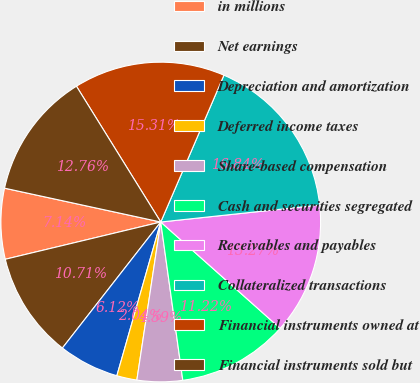Convert chart. <chart><loc_0><loc_0><loc_500><loc_500><pie_chart><fcel>in millions<fcel>Net earnings<fcel>Depreciation and amortization<fcel>Deferred income taxes<fcel>Share-based compensation<fcel>Cash and securities segregated<fcel>Receivables and payables<fcel>Collateralized transactions<fcel>Financial instruments owned at<fcel>Financial instruments sold but<nl><fcel>7.14%<fcel>10.71%<fcel>6.12%<fcel>2.04%<fcel>4.59%<fcel>11.22%<fcel>13.27%<fcel>16.84%<fcel>15.31%<fcel>12.76%<nl></chart> 